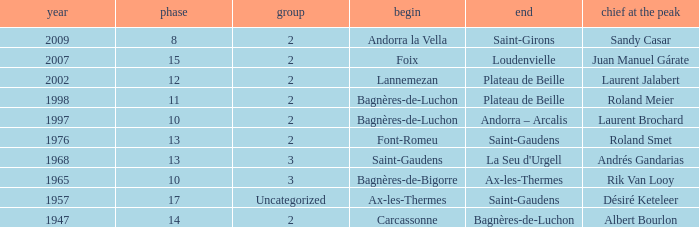Give the Finish for years after 2007. Saint-Girons. 